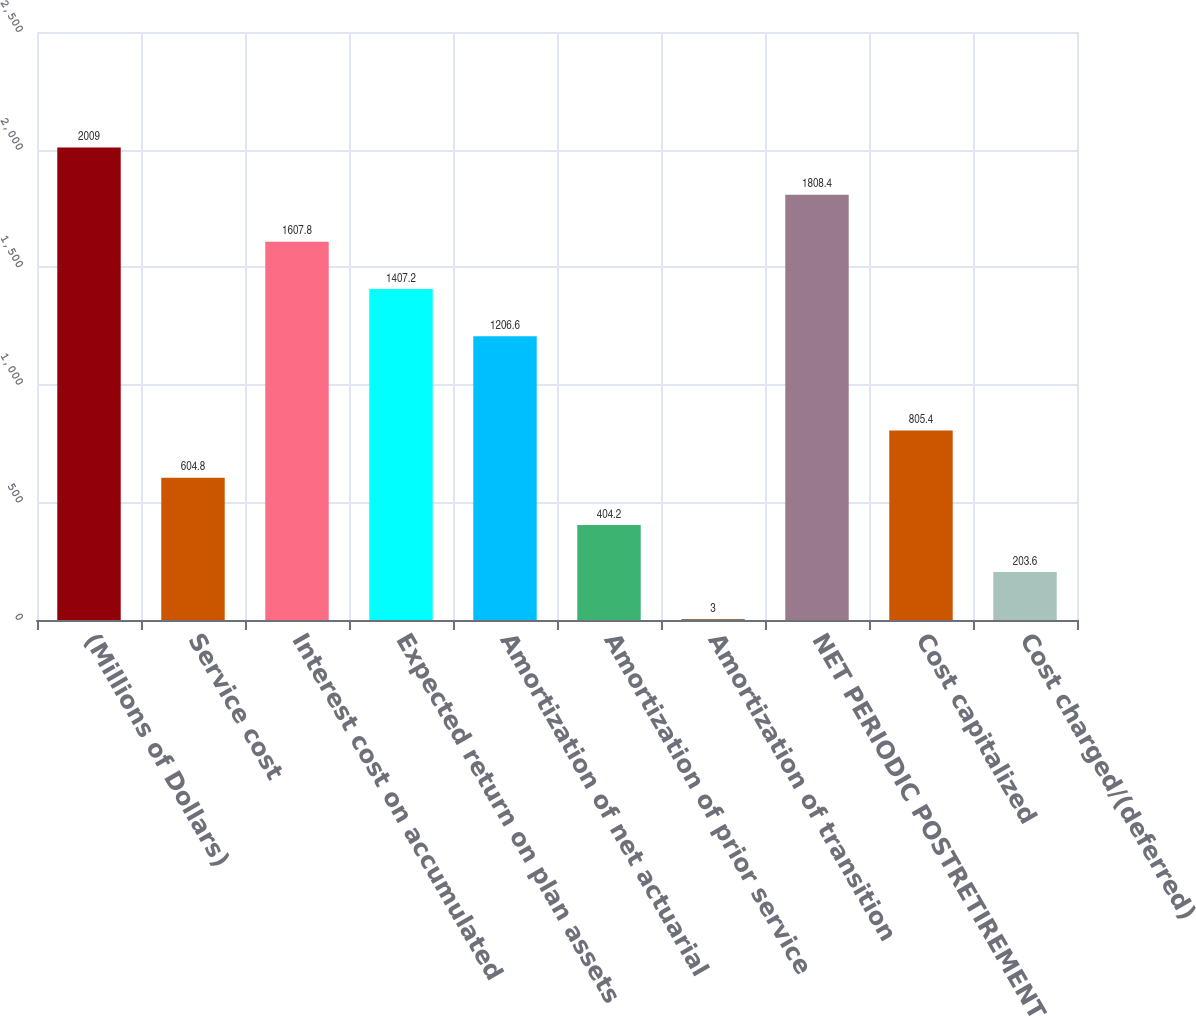Convert chart. <chart><loc_0><loc_0><loc_500><loc_500><bar_chart><fcel>(Millions of Dollars)<fcel>Service cost<fcel>Interest cost on accumulated<fcel>Expected return on plan assets<fcel>Amortization of net actuarial<fcel>Amortization of prior service<fcel>Amortization of transition<fcel>NET PERIODIC POSTRETIREMENT<fcel>Cost capitalized<fcel>Cost charged/(deferred)<nl><fcel>2009<fcel>604.8<fcel>1607.8<fcel>1407.2<fcel>1206.6<fcel>404.2<fcel>3<fcel>1808.4<fcel>805.4<fcel>203.6<nl></chart> 